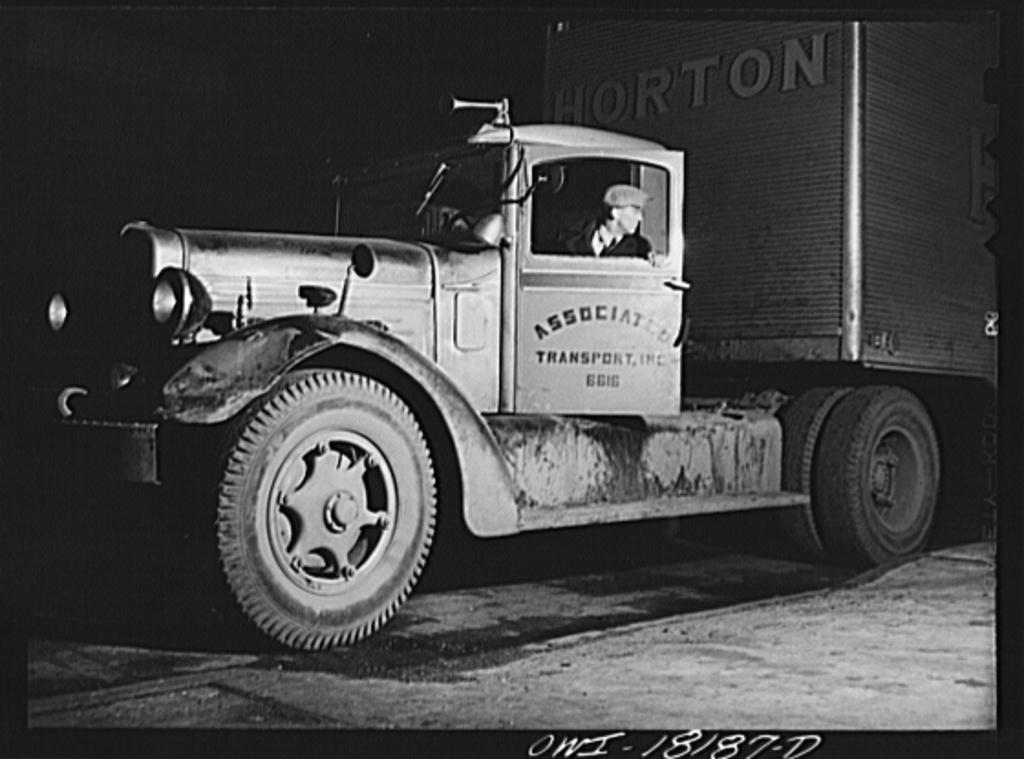What is the main subject of the image? There is a vehicle on the road in the image. Can you describe the vehicle's occupant? There is a person in the vehicle. What can be observed about the lighting in the image? The background of the image is dark. What additional information is provided at the bottom of the image? There is text visible at the bottom of the image. What type of canvas is being used to paint the apple in the image? There is no canvas, apple, or painting present in the image. 